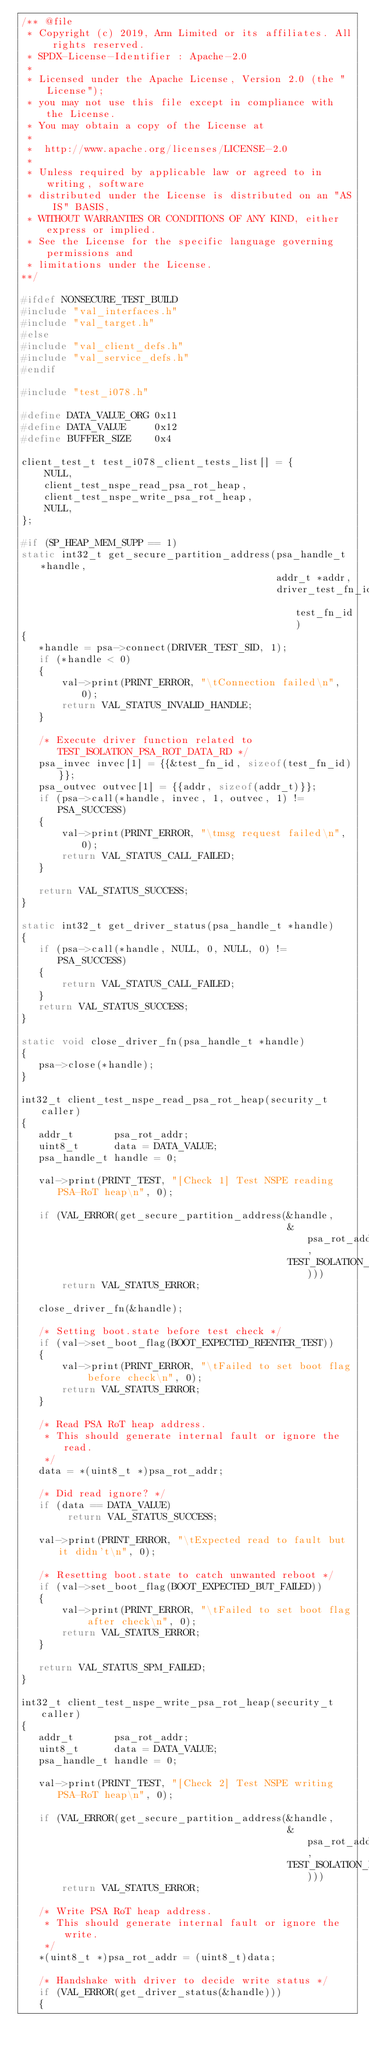Convert code to text. <code><loc_0><loc_0><loc_500><loc_500><_C_>/** @file
 * Copyright (c) 2019, Arm Limited or its affiliates. All rights reserved.
 * SPDX-License-Identifier : Apache-2.0
 *
 * Licensed under the Apache License, Version 2.0 (the "License");
 * you may not use this file except in compliance with the License.
 * You may obtain a copy of the License at
 *
 *  http://www.apache.org/licenses/LICENSE-2.0
 *
 * Unless required by applicable law or agreed to in writing, software
 * distributed under the License is distributed on an "AS IS" BASIS,
 * WITHOUT WARRANTIES OR CONDITIONS OF ANY KIND, either express or implied.
 * See the License for the specific language governing permissions and
 * limitations under the License.
**/

#ifdef NONSECURE_TEST_BUILD
#include "val_interfaces.h"
#include "val_target.h"
#else
#include "val_client_defs.h"
#include "val_service_defs.h"
#endif

#include "test_i078.h"

#define DATA_VALUE_ORG 0x11
#define DATA_VALUE     0x12
#define BUFFER_SIZE    0x4

client_test_t test_i078_client_tests_list[] = {
    NULL,
    client_test_nspe_read_psa_rot_heap,
    client_test_nspe_write_psa_rot_heap,
    NULL,
};

#if (SP_HEAP_MEM_SUPP == 1)
static int32_t get_secure_partition_address(psa_handle_t *handle,
                                            addr_t *addr,
                                            driver_test_fn_id_t test_fn_id)
{
   *handle = psa->connect(DRIVER_TEST_SID, 1);
   if (*handle < 0)
   {
       val->print(PRINT_ERROR, "\tConnection failed\n", 0);
       return VAL_STATUS_INVALID_HANDLE;
   }

   /* Execute driver function related to TEST_ISOLATION_PSA_ROT_DATA_RD */
   psa_invec invec[1] = {{&test_fn_id, sizeof(test_fn_id)}};
   psa_outvec outvec[1] = {{addr, sizeof(addr_t)}};
   if (psa->call(*handle, invec, 1, outvec, 1) != PSA_SUCCESS)
   {
       val->print(PRINT_ERROR, "\tmsg request failed\n", 0);
       return VAL_STATUS_CALL_FAILED;
   }

   return VAL_STATUS_SUCCESS;
}

static int32_t get_driver_status(psa_handle_t *handle)
{
   if (psa->call(*handle, NULL, 0, NULL, 0) != PSA_SUCCESS)
   {
       return VAL_STATUS_CALL_FAILED;
   }
   return VAL_STATUS_SUCCESS;
}

static void close_driver_fn(psa_handle_t *handle)
{
   psa->close(*handle);
}

int32_t client_test_nspe_read_psa_rot_heap(security_t caller)
{
   addr_t       psa_rot_addr;
   uint8_t      data = DATA_VALUE;
   psa_handle_t handle = 0;

   val->print(PRINT_TEST, "[Check 1] Test NSPE reading PSA-RoT heap\n", 0);

   if (VAL_ERROR(get_secure_partition_address(&handle,
                                              &psa_rot_addr,
                                              TEST_ISOLATION_PSA_ROT_HEAP_RD)))
       return VAL_STATUS_ERROR;

   close_driver_fn(&handle);

   /* Setting boot.state before test check */
   if (val->set_boot_flag(BOOT_EXPECTED_REENTER_TEST))
   {
       val->print(PRINT_ERROR, "\tFailed to set boot flag before check\n", 0);
       return VAL_STATUS_ERROR;
   }

   /* Read PSA RoT heap address.
    * This should generate internal fault or ignore the read.
    */
   data = *(uint8_t *)psa_rot_addr;

   /* Did read ignore? */
   if (data == DATA_VALUE)
        return VAL_STATUS_SUCCESS;

   val->print(PRINT_ERROR, "\tExpected read to fault but it didn't\n", 0);

   /* Resetting boot.state to catch unwanted reboot */
   if (val->set_boot_flag(BOOT_EXPECTED_BUT_FAILED))
   {
       val->print(PRINT_ERROR, "\tFailed to set boot flag after check\n", 0);
       return VAL_STATUS_ERROR;
   }

   return VAL_STATUS_SPM_FAILED;
}

int32_t client_test_nspe_write_psa_rot_heap(security_t caller)
{
   addr_t       psa_rot_addr;
   uint8_t      data = DATA_VALUE;
   psa_handle_t handle = 0;

   val->print(PRINT_TEST, "[Check 2] Test NSPE writing PSA-RoT heap\n", 0);

   if (VAL_ERROR(get_secure_partition_address(&handle,
                                              &psa_rot_addr,
                                              TEST_ISOLATION_PSA_ROT_HEAP_WR)))
       return VAL_STATUS_ERROR;

   /* Write PSA RoT heap address.
    * This should generate internal fault or ignore the write.
    */
   *(uint8_t *)psa_rot_addr = (uint8_t)data;

   /* Handshake with driver to decide write status */
   if (VAL_ERROR(get_driver_status(&handle)))
   {</code> 